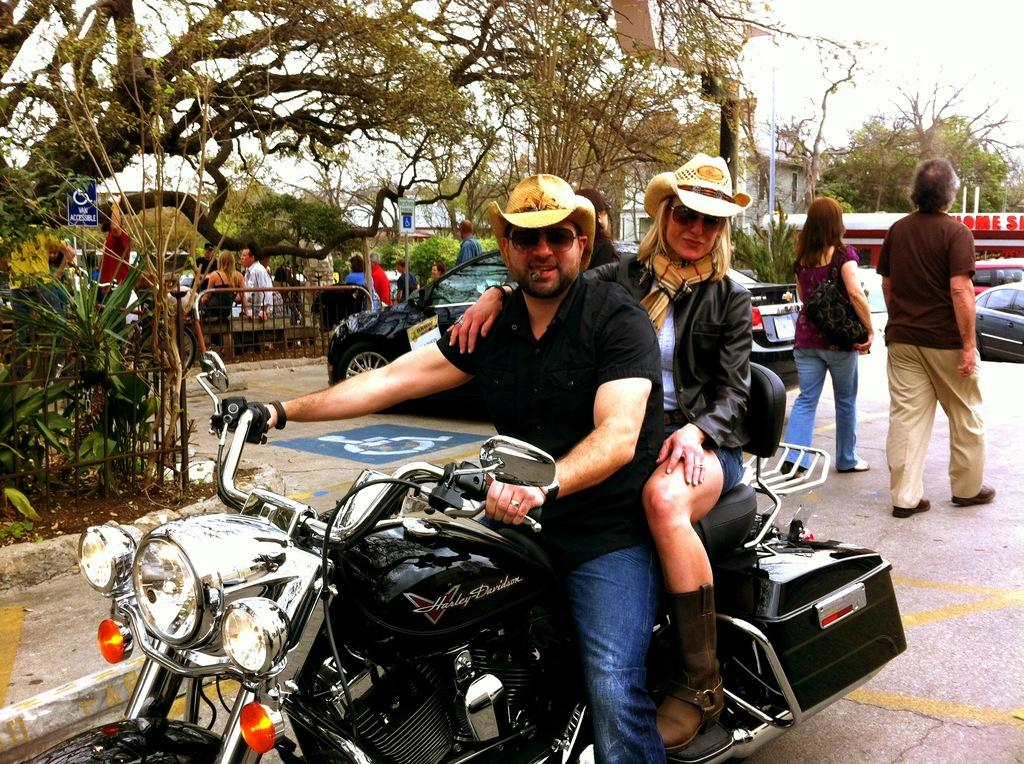What type of vegetation can be seen in the image? There are trees in the image. What are the people in the image doing? The people in the image are standing and sitting. What vehicles are present in the image? There is a car and a motorcycle in the image. How many people are on the motorcycle? There are two persons on the motorcycle. Can you find the receipt for the car purchase in the image? There is no receipt present in the image. What type of thrill can be experienced by the persons on the motorcycle in the image? The image does not convey any specific emotions or experiences of the persons on the motorcycle. 